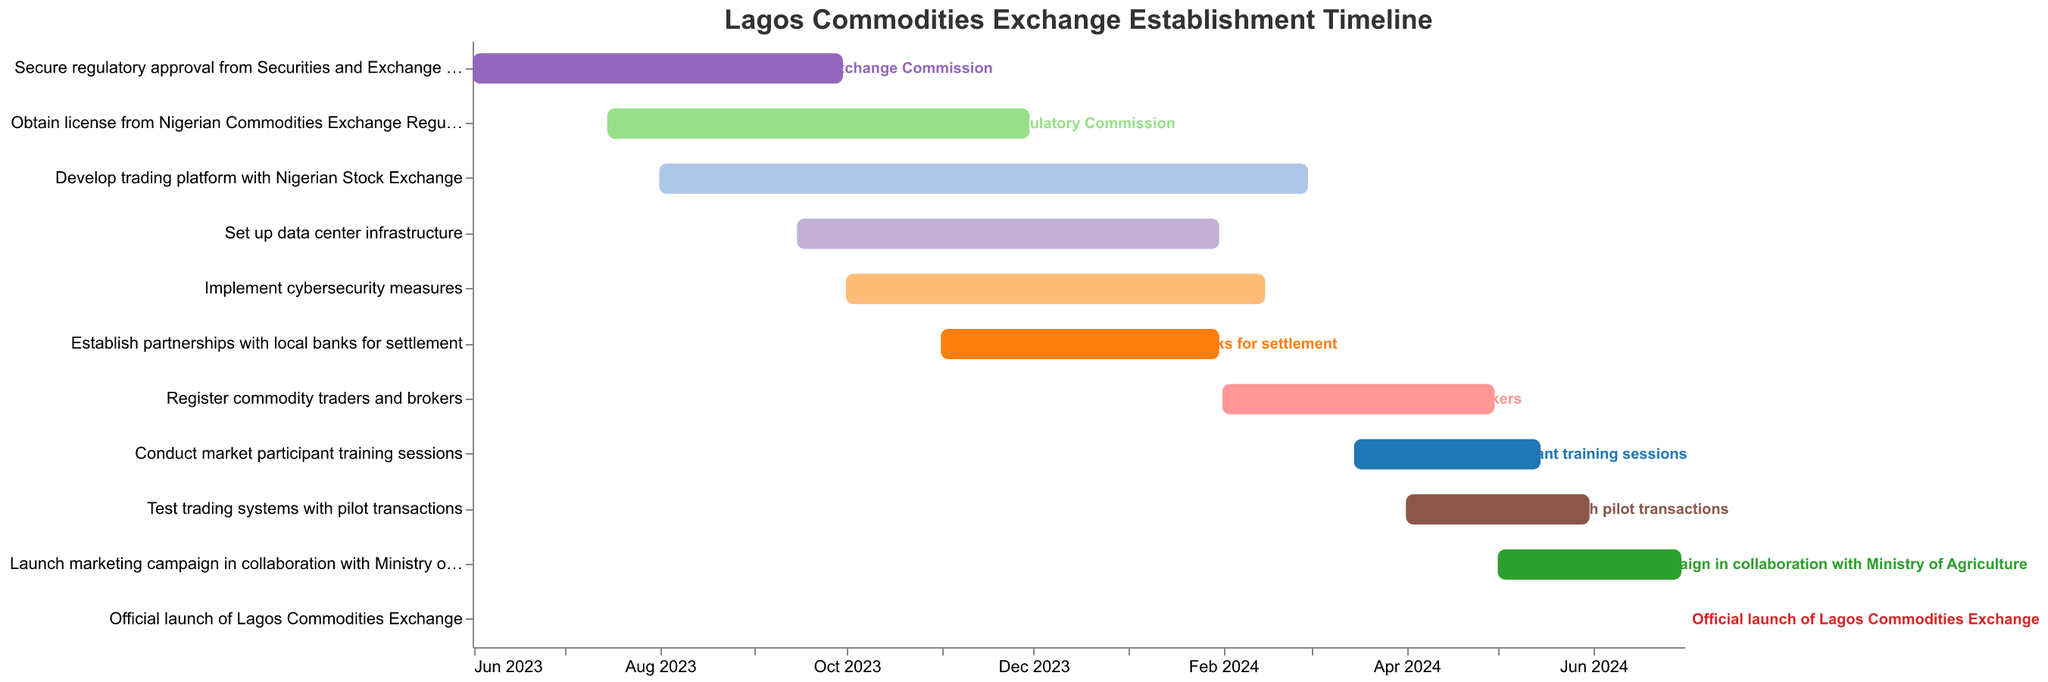When does the task "Secure regulatory approval from Securities and Exchange Commission" start and end? Look for "Secure regulatory approval from Securities and Exchange Commission" in the tasks list, and read the "Start Date" and "End Date" values which are "2023-06-01" and "2023-09-30" respectively.
Answer: 2023-06-01 to 2023-09-30 How long will the "Develop trading platform with Nigerian Stock Exchange" task take to complete? Identify the start and end dates of the task "Develop trading platform with Nigerian Stock Exchange", then calculate the difference between "2023-08-01" and "2024-02-29" which is 7 months.
Answer: 7 months Which task will be ongoing during January 2024? Identify the tasks overlapping with January 2024 by checking their start and end dates. The relevant tasks are: "Develop trading platform with Nigerian Stock Exchange", "Set up data center infrastructure", "Implement cybersecurity measures", and "Establish partnerships with local banks for settlement".
Answer: Develop trading platform with Nigerian Stock Exchange, Set up data center infrastructure, Implement cybersecurity measures, and Establish partnerships with local banks for settlement What is the duration between the start of the task "Register commodity traders and brokers" and the end of the "Conduct market participant training sessions" task? Identify the start date of "Register commodity traders and brokers" which is "2024-02-01" and the end date of "Conduct market participant training sessions" which is "2024-05-15", then calculate the difference in days between these two dates.
Answer: 104 days Compare the durations of "Obtain license from Nigerian Commodities Exchange Regulatory Commission" and "Implement cybersecurity measures". Which one takes longer? Calculate the durations for both tasks: "Obtain license from Nigerian Commodities Exchange Regulatory Commission" from "2023-07-15" to "2023-11-30" (4.5 months) and "Implement cybersecurity measures" from "2023-10-01" to "2024-02-15" (4.5 months). Both tasks have approximately the same duration.
Answer: Both are equal Which task marks the official launch of the Lagos Commodities Exchange? Locate the task with the description including "official launch" which is "Official launch of Lagos Commodities Exchange" and note the corresponding date.
Answer: Official launch of Lagos Commodities Exchange on 2024-07-01 What is the range of months covered by the entire project timeline? Identify the start date of the earliest task, "Secure regulatory approval from Securities and Exchange Commission" which is "2023-06-01", and the end date of the latest task, "Official launch of Lagos Commodities Exchange" which is "2024-07-01". The timeline spans from June 2023 to July 2024.
Answer: June 2023 to July 2024 How many tasks overlap with the "Set up data center infrastructure" task? Identify the start and end dates of "Set up data center infrastructure" ("2023-09-15" to "2024-01-31") and count the tasks whose timelines overlap with these dates. These tasks are: "Develop trading platform with Nigerian Stock Exchange", "Implement cybersecurity measures", "Establish partnerships with local banks for settlement", and "Obtain license from Nigerian Commodities Exchange Regulatory Commission".
Answer: 4 